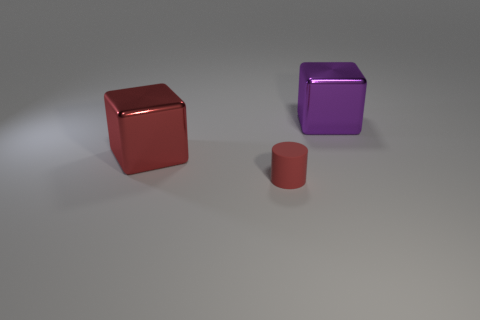Add 3 red metal blocks. How many objects exist? 6 Subtract all blocks. How many objects are left? 1 Add 1 shiny objects. How many shiny objects are left? 3 Add 1 large cubes. How many large cubes exist? 3 Subtract 0 brown spheres. How many objects are left? 3 Subtract all red metallic cubes. Subtract all red rubber objects. How many objects are left? 1 